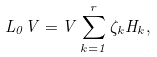<formula> <loc_0><loc_0><loc_500><loc_500>L _ { 0 } V = V \sum _ { k = 1 } ^ { r } \zeta _ { k } H _ { k } ,</formula> 